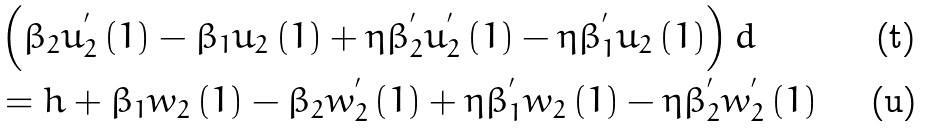<formula> <loc_0><loc_0><loc_500><loc_500>& \left ( \beta _ { 2 } u _ { 2 } ^ { ^ { \prime } } \left ( 1 \right ) - \beta _ { 1 } u _ { 2 } \left ( 1 \right ) + \eta \beta _ { 2 } ^ { ^ { \prime } } u _ { 2 } ^ { ^ { \prime } } \left ( 1 \right ) - \eta \beta _ { 1 } ^ { ^ { \prime } } u _ { 2 } \left ( 1 \right ) \right ) d \\ & = h + \beta _ { 1 } w _ { 2 } \left ( 1 \right ) - \beta _ { 2 } w _ { 2 } ^ { ^ { \prime } } \left ( 1 \right ) + \eta \beta _ { 1 } ^ { ^ { \prime } } w _ { 2 } \left ( 1 \right ) - \eta \beta _ { 2 } ^ { ^ { \prime } } w _ { 2 } ^ { ^ { \prime } } \left ( 1 \right )</formula> 